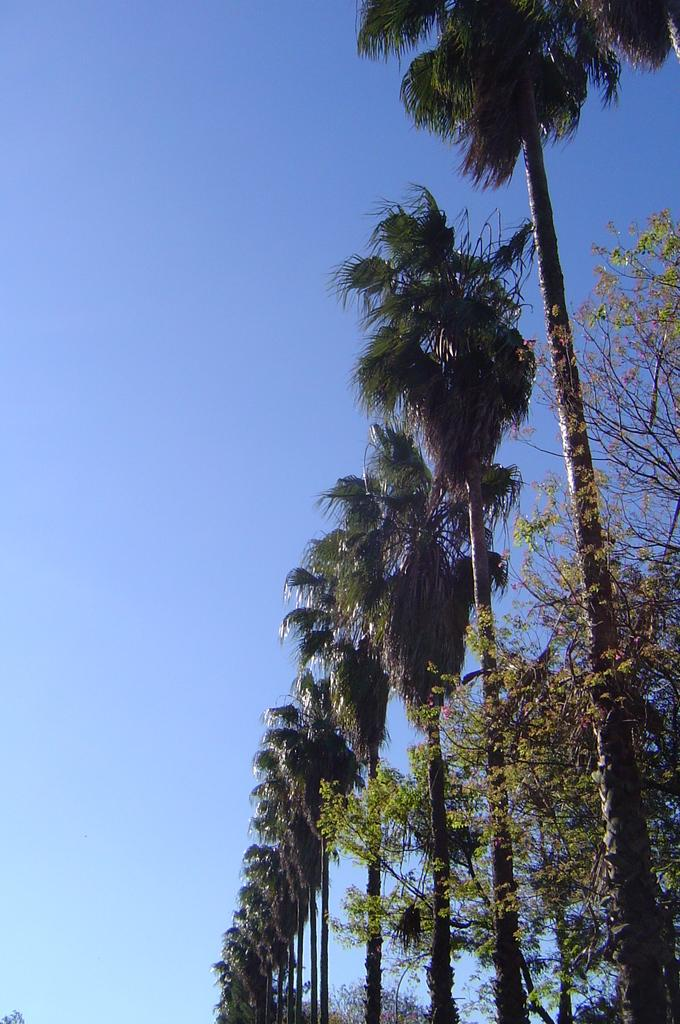What type of vegetation can be seen in the image? There are tall trees in the image. How are the trees arranged in the image? The trees are in a line. What is visible at the top of the image? The sky is visible at the top of the image. What can be seen on the right side of the image? There is a plant on the right side of the image. What is the temperature of the mark on the division in the image? There is no mention of a mark or division in the image; it features tall trees in a line with the sky visible at the top and a plant on the right side. 